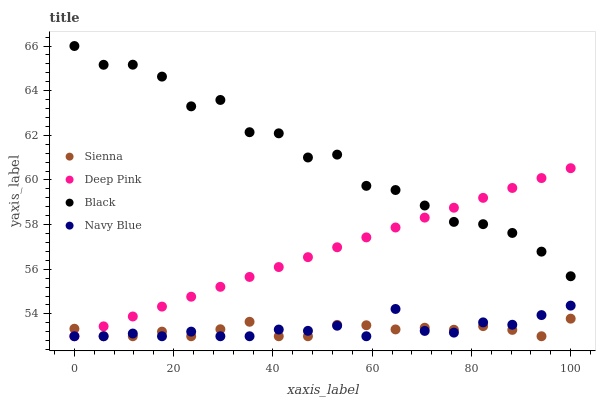Does Sienna have the minimum area under the curve?
Answer yes or no. Yes. Does Black have the maximum area under the curve?
Answer yes or no. Yes. Does Navy Blue have the minimum area under the curve?
Answer yes or no. No. Does Navy Blue have the maximum area under the curve?
Answer yes or no. No. Is Deep Pink the smoothest?
Answer yes or no. Yes. Is Black the roughest?
Answer yes or no. Yes. Is Navy Blue the smoothest?
Answer yes or no. No. Is Navy Blue the roughest?
Answer yes or no. No. Does Sienna have the lowest value?
Answer yes or no. Yes. Does Black have the lowest value?
Answer yes or no. No. Does Black have the highest value?
Answer yes or no. Yes. Does Navy Blue have the highest value?
Answer yes or no. No. Is Navy Blue less than Black?
Answer yes or no. Yes. Is Black greater than Sienna?
Answer yes or no. Yes. Does Navy Blue intersect Deep Pink?
Answer yes or no. Yes. Is Navy Blue less than Deep Pink?
Answer yes or no. No. Is Navy Blue greater than Deep Pink?
Answer yes or no. No. Does Navy Blue intersect Black?
Answer yes or no. No. 